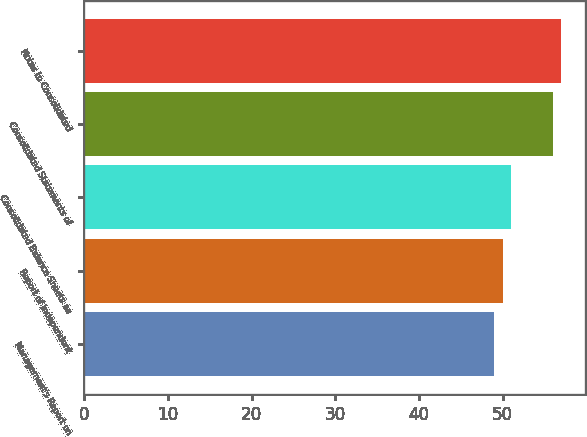Convert chart. <chart><loc_0><loc_0><loc_500><loc_500><bar_chart><fcel>Management's Report on<fcel>Report of Independent<fcel>Consolidated Balance Sheets as<fcel>Consolidated Statements of<fcel>Notes to Consolidated<nl><fcel>49<fcel>50<fcel>51<fcel>56<fcel>57<nl></chart> 